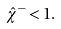Convert formula to latex. <formula><loc_0><loc_0><loc_500><loc_500>\hat { \chi } ^ { - } < 1 .</formula> 